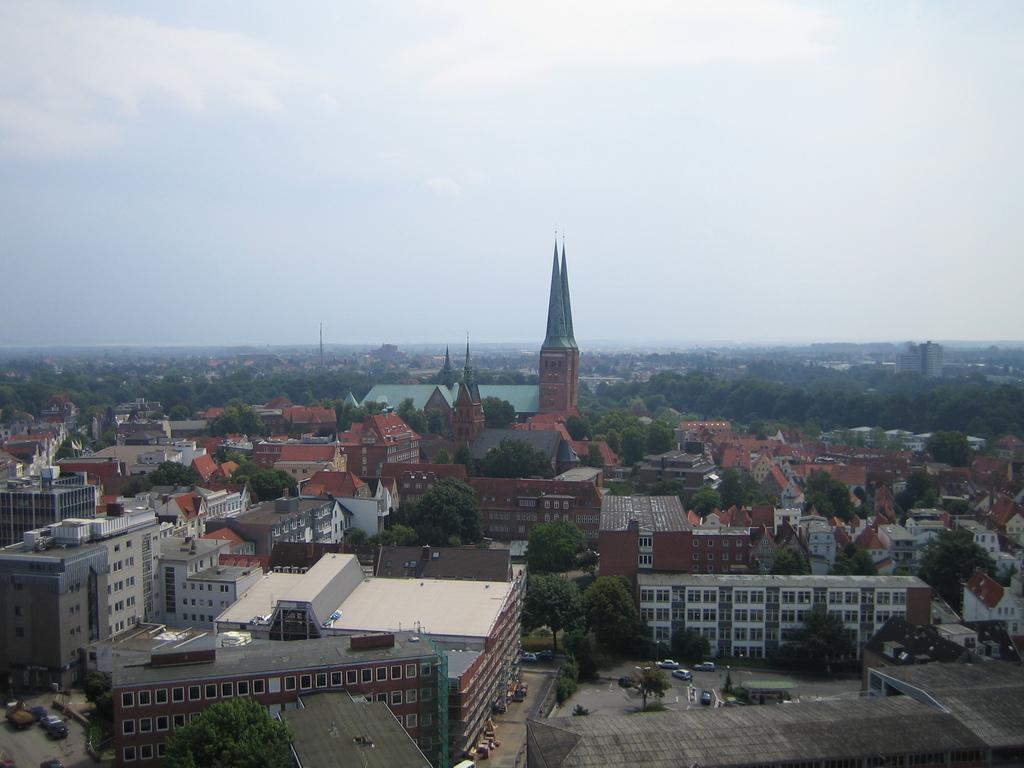Can you describe this image briefly? This is an aerial view in this image there are houses, towers, trees, vehicles and the sky. 